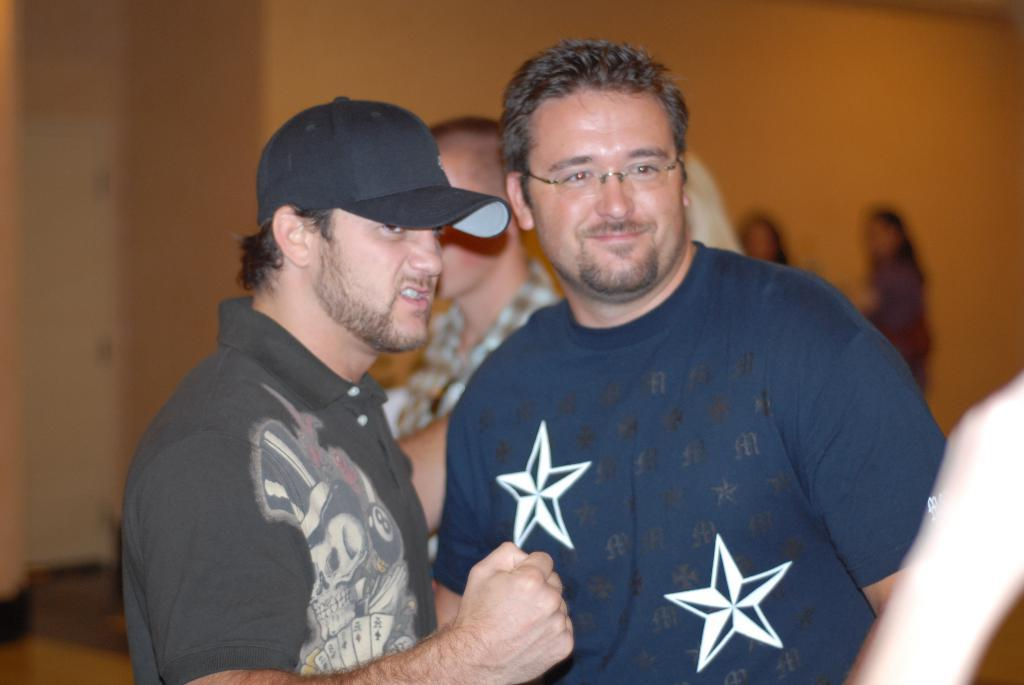How many individuals are present in the image? There are many people in the image. Can you describe the headwear of the person on the left? The person on the left is wearing a cap. What type of eyewear is the person on the right wearing? The person on the right is wearing glasses (specs). What can be seen in the background of the image? There is a wall in the background of the image. How does the donkey transport the people in the image? There is no donkey present in the image, so it cannot be used to transport people. 